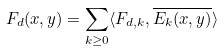<formula> <loc_0><loc_0><loc_500><loc_500>F _ { d } ( x , y ) = \sum _ { k \geq 0 } \langle F _ { d , k } , \overline { E _ { k } ( x , y ) } \rangle</formula> 